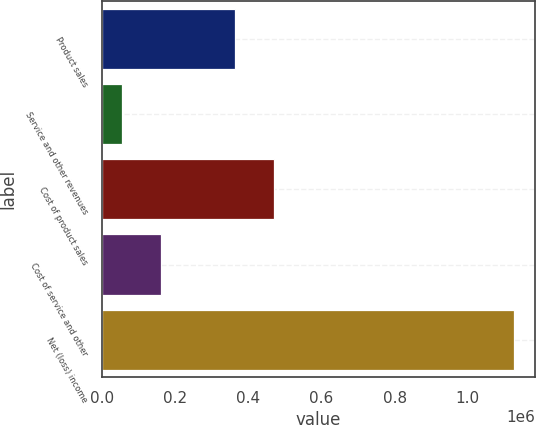<chart> <loc_0><loc_0><loc_500><loc_500><bar_chart><fcel>Product sales<fcel>Service and other revenues<fcel>Cost of product sales<fcel>Cost of service and other<fcel>Net (loss) income<nl><fcel>362836<fcel>53621<fcel>470174<fcel>160958<fcel>1.127e+06<nl></chart> 